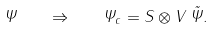Convert formula to latex. <formula><loc_0><loc_0><loc_500><loc_500>\Psi \quad \Rightarrow \quad \Psi _ { c } = S \otimes V \, \tilde { \Psi } .</formula> 